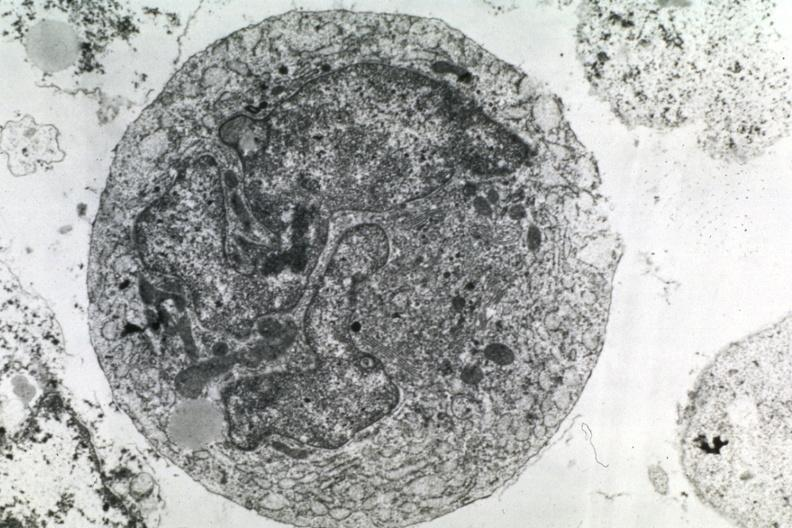s fetus developing very early present?
Answer the question using a single word or phrase. No 